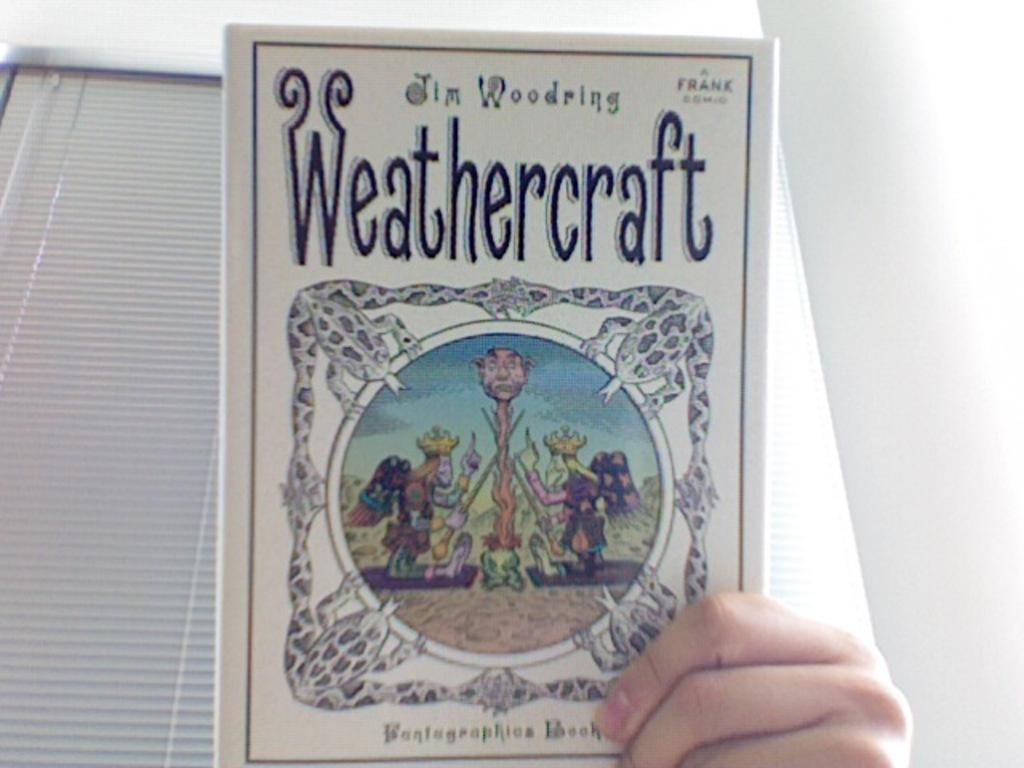Provide a one-sentence caption for the provided image. Someone holding a book with the title Weathercraft. 